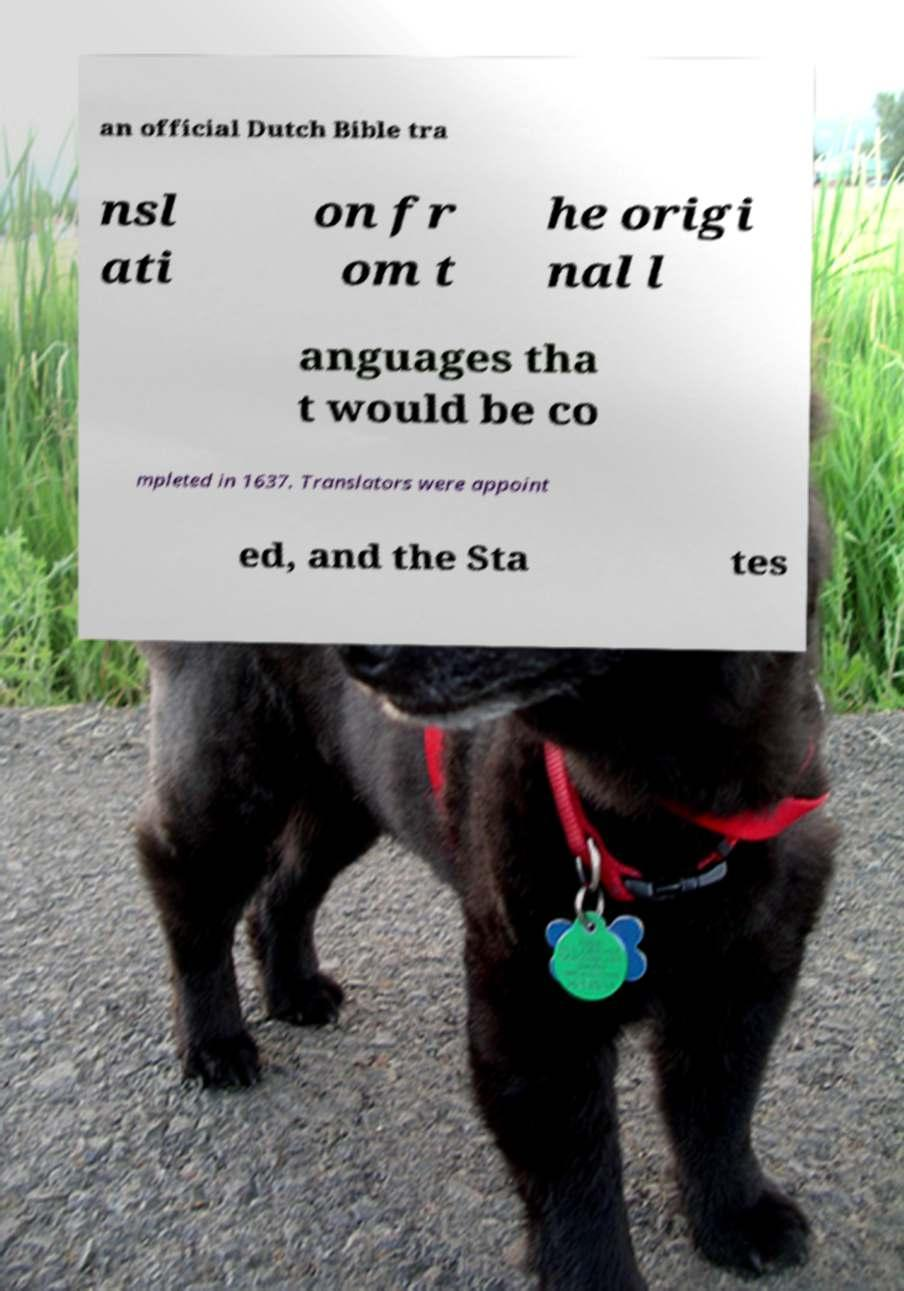Please identify and transcribe the text found in this image. an official Dutch Bible tra nsl ati on fr om t he origi nal l anguages tha t would be co mpleted in 1637. Translators were appoint ed, and the Sta tes 